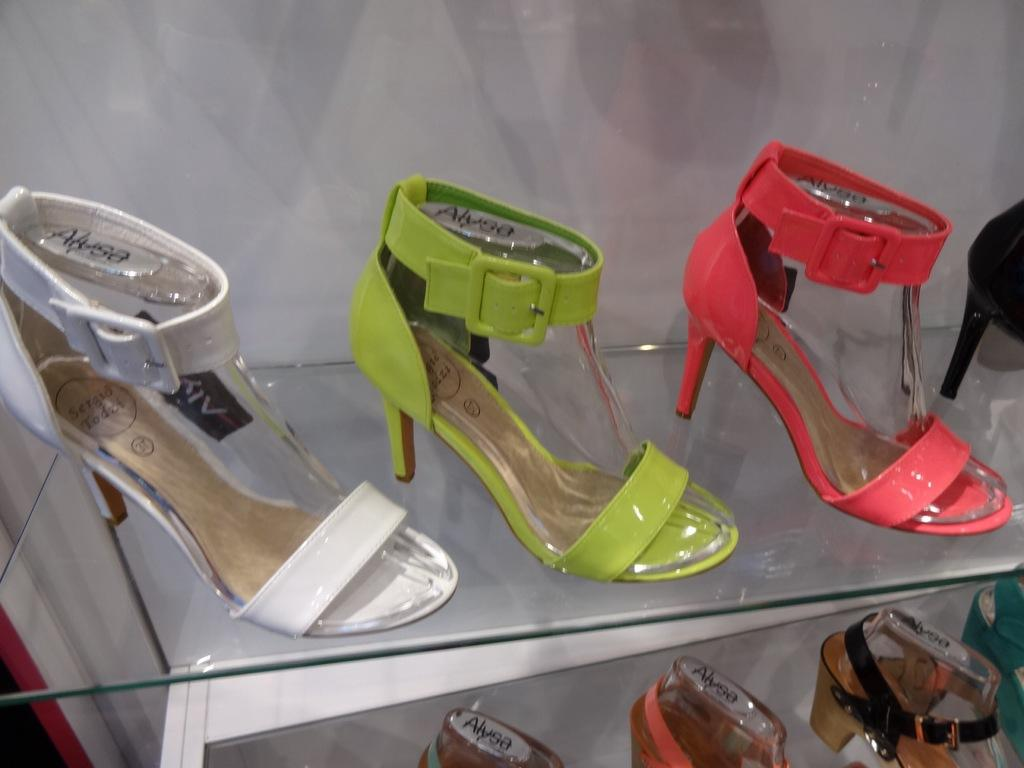<image>
Write a terse but informative summary of the picture. Alyssa heels with ankle straps in white, green and pink. 